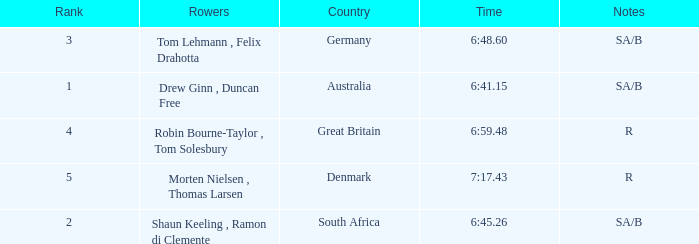What was the highest rank for rowers who represented Denmark? 5.0. 